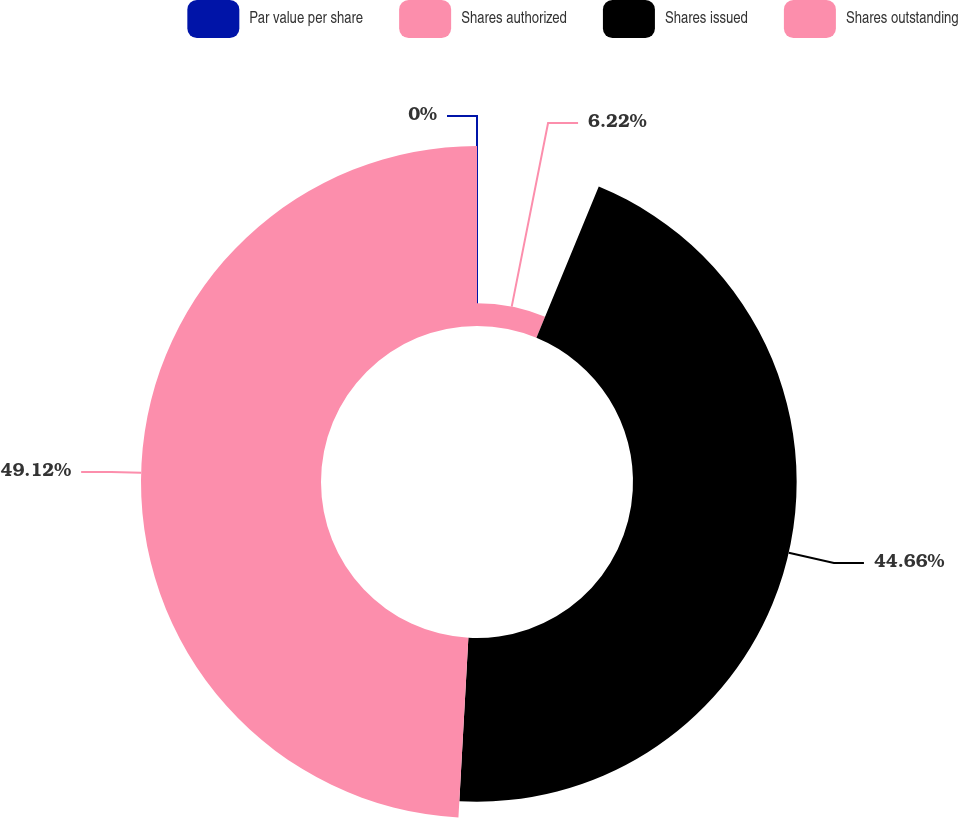Convert chart. <chart><loc_0><loc_0><loc_500><loc_500><pie_chart><fcel>Par value per share<fcel>Shares authorized<fcel>Shares issued<fcel>Shares outstanding<nl><fcel>0.0%<fcel>6.22%<fcel>44.66%<fcel>49.12%<nl></chart> 